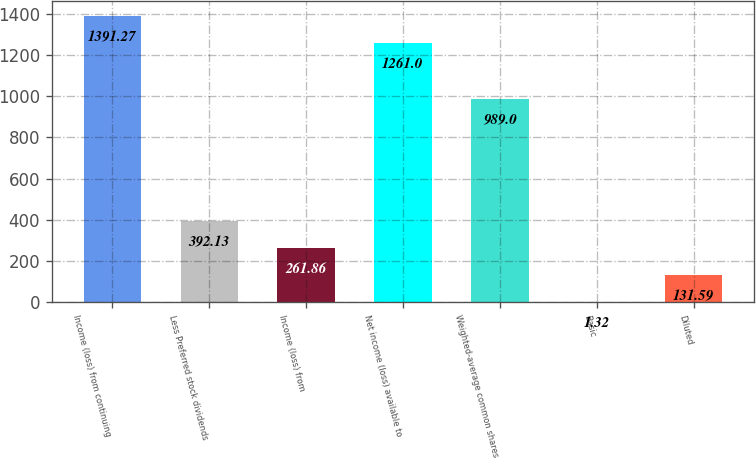Convert chart to OTSL. <chart><loc_0><loc_0><loc_500><loc_500><bar_chart><fcel>Income (loss) from continuing<fcel>Less Preferred stock dividends<fcel>Income (loss) from<fcel>Net income (loss) available to<fcel>Weighted-average common shares<fcel>Basic<fcel>Diluted<nl><fcel>1391.27<fcel>392.13<fcel>261.86<fcel>1261<fcel>989<fcel>1.32<fcel>131.59<nl></chart> 